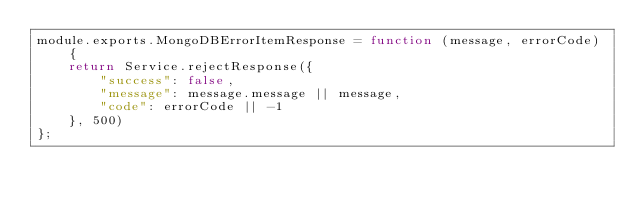Convert code to text. <code><loc_0><loc_0><loc_500><loc_500><_JavaScript_>module.exports.MongoDBErrorItemResponse = function (message, errorCode) {
    return Service.rejectResponse({
        "success": false,
        "message": message.message || message,
        "code": errorCode || -1
    }, 500)
};
</code> 